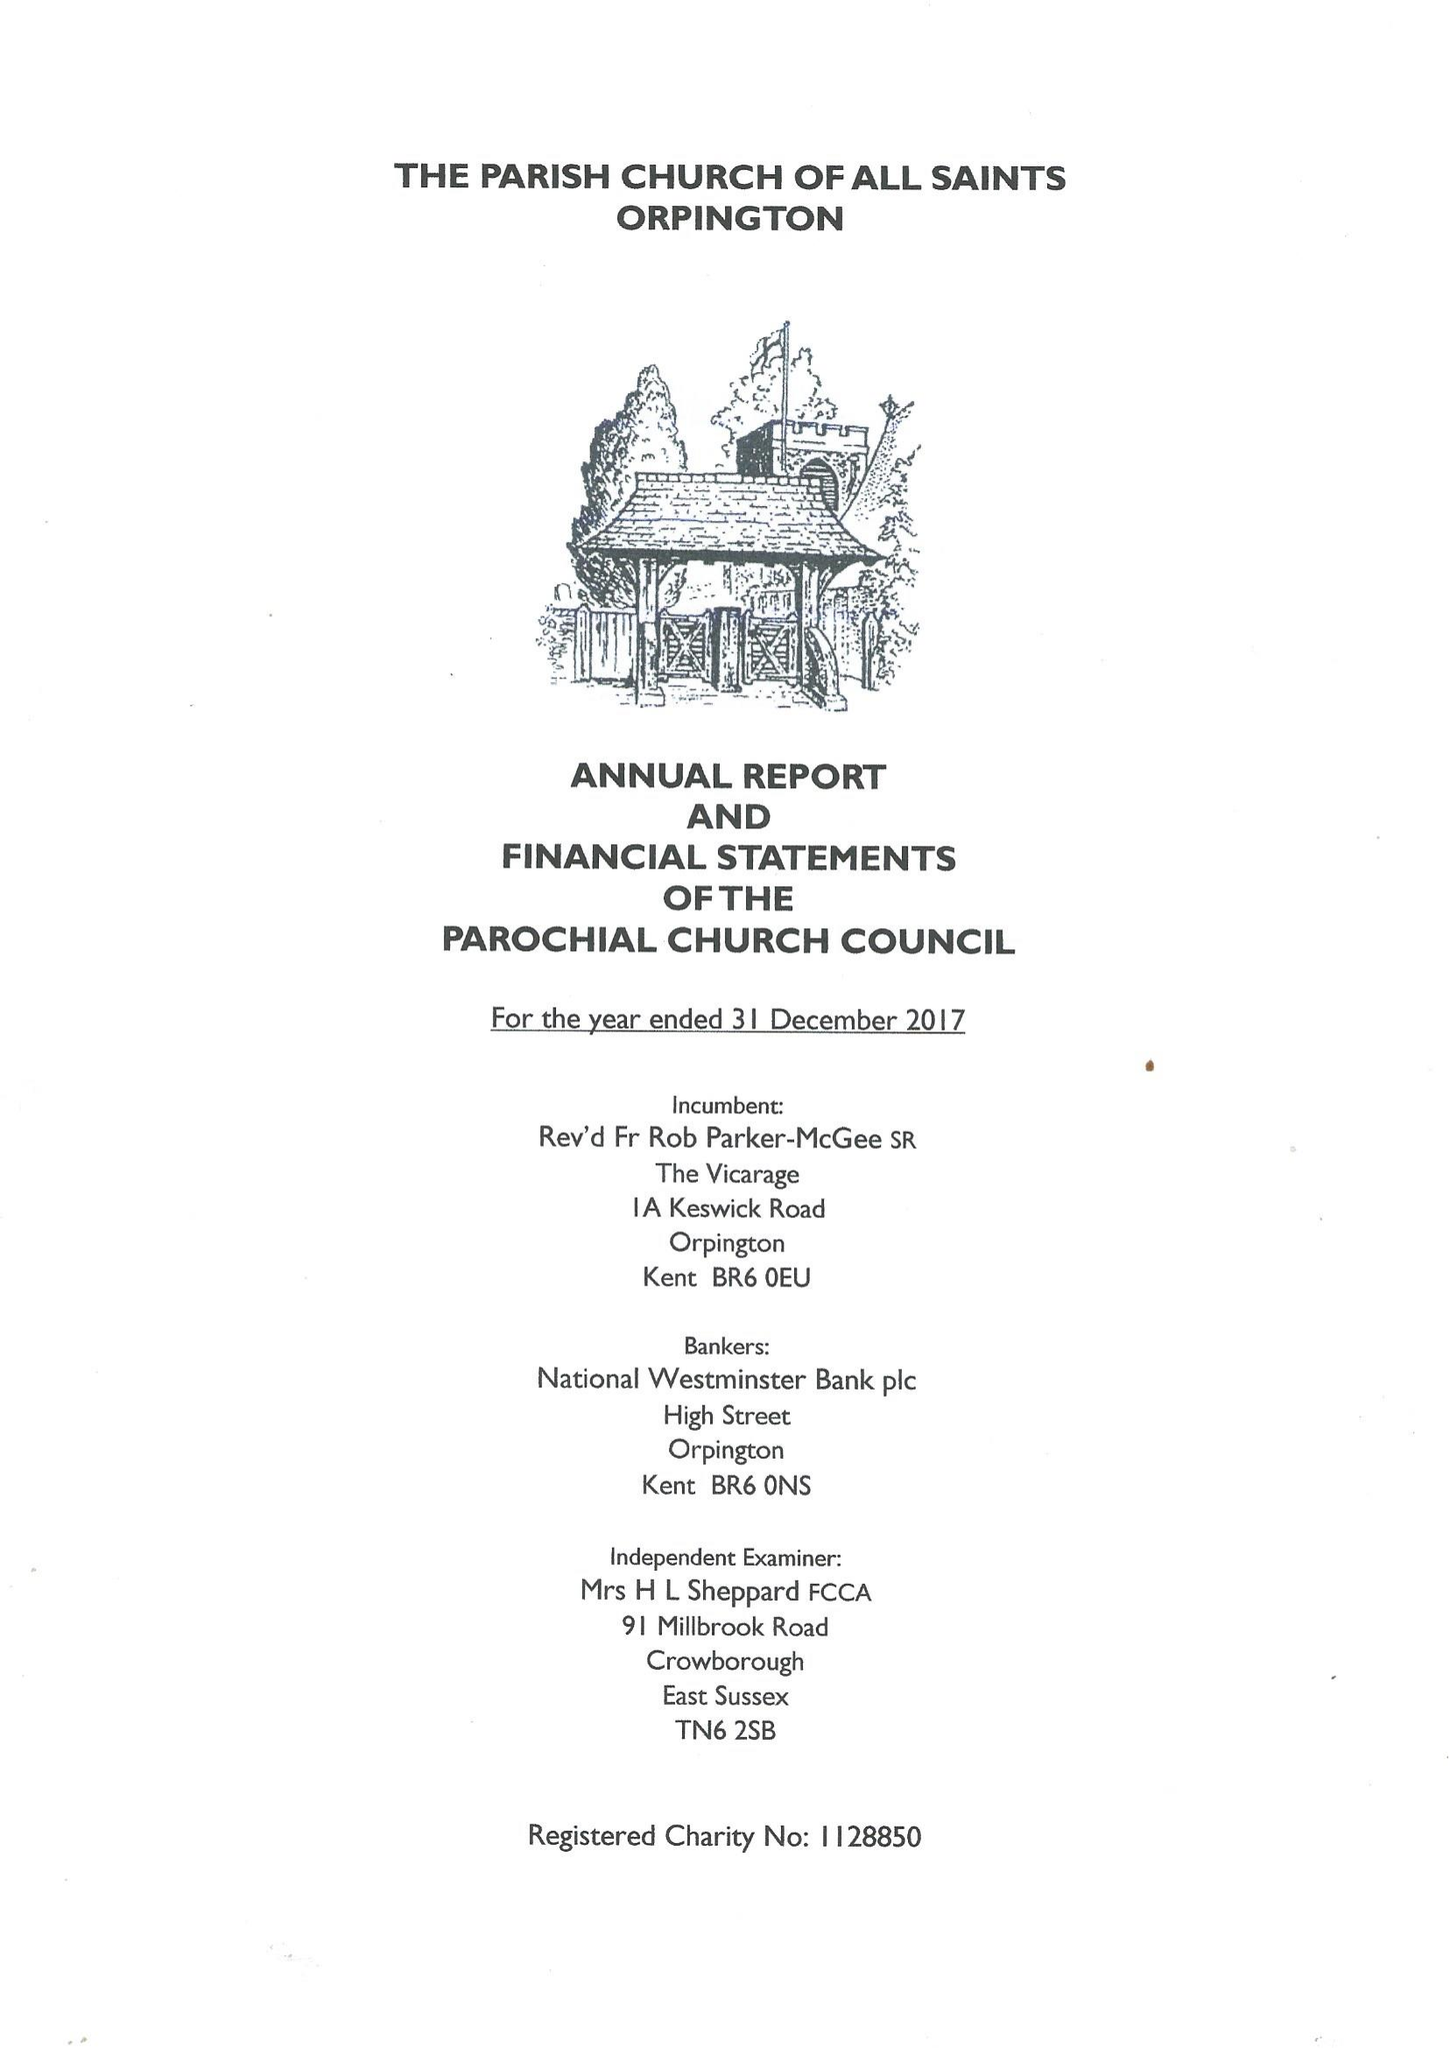What is the value for the charity_number?
Answer the question using a single word or phrase. 1128850 